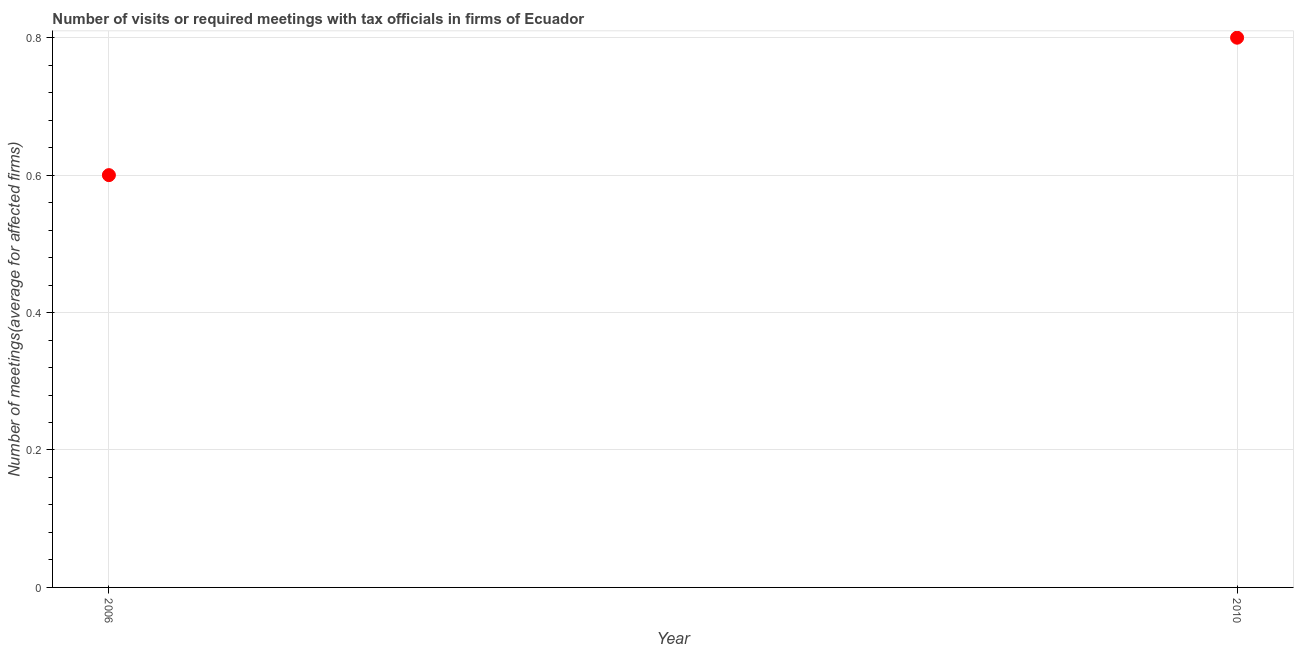What is the number of required meetings with tax officials in 2006?
Your response must be concise. 0.6. Across all years, what is the maximum number of required meetings with tax officials?
Your answer should be very brief. 0.8. What is the difference between the number of required meetings with tax officials in 2006 and 2010?
Offer a terse response. -0.2. Do a majority of the years between 2006 and 2010 (inclusive) have number of required meetings with tax officials greater than 0.16 ?
Ensure brevity in your answer.  Yes. What is the ratio of the number of required meetings with tax officials in 2006 to that in 2010?
Offer a terse response. 0.75. Are the values on the major ticks of Y-axis written in scientific E-notation?
Keep it short and to the point. No. Does the graph contain grids?
Provide a short and direct response. Yes. What is the title of the graph?
Provide a short and direct response. Number of visits or required meetings with tax officials in firms of Ecuador. What is the label or title of the X-axis?
Give a very brief answer. Year. What is the label or title of the Y-axis?
Offer a very short reply. Number of meetings(average for affected firms). What is the Number of meetings(average for affected firms) in 2010?
Your answer should be compact. 0.8. What is the difference between the Number of meetings(average for affected firms) in 2006 and 2010?
Your answer should be very brief. -0.2. What is the ratio of the Number of meetings(average for affected firms) in 2006 to that in 2010?
Your answer should be very brief. 0.75. 